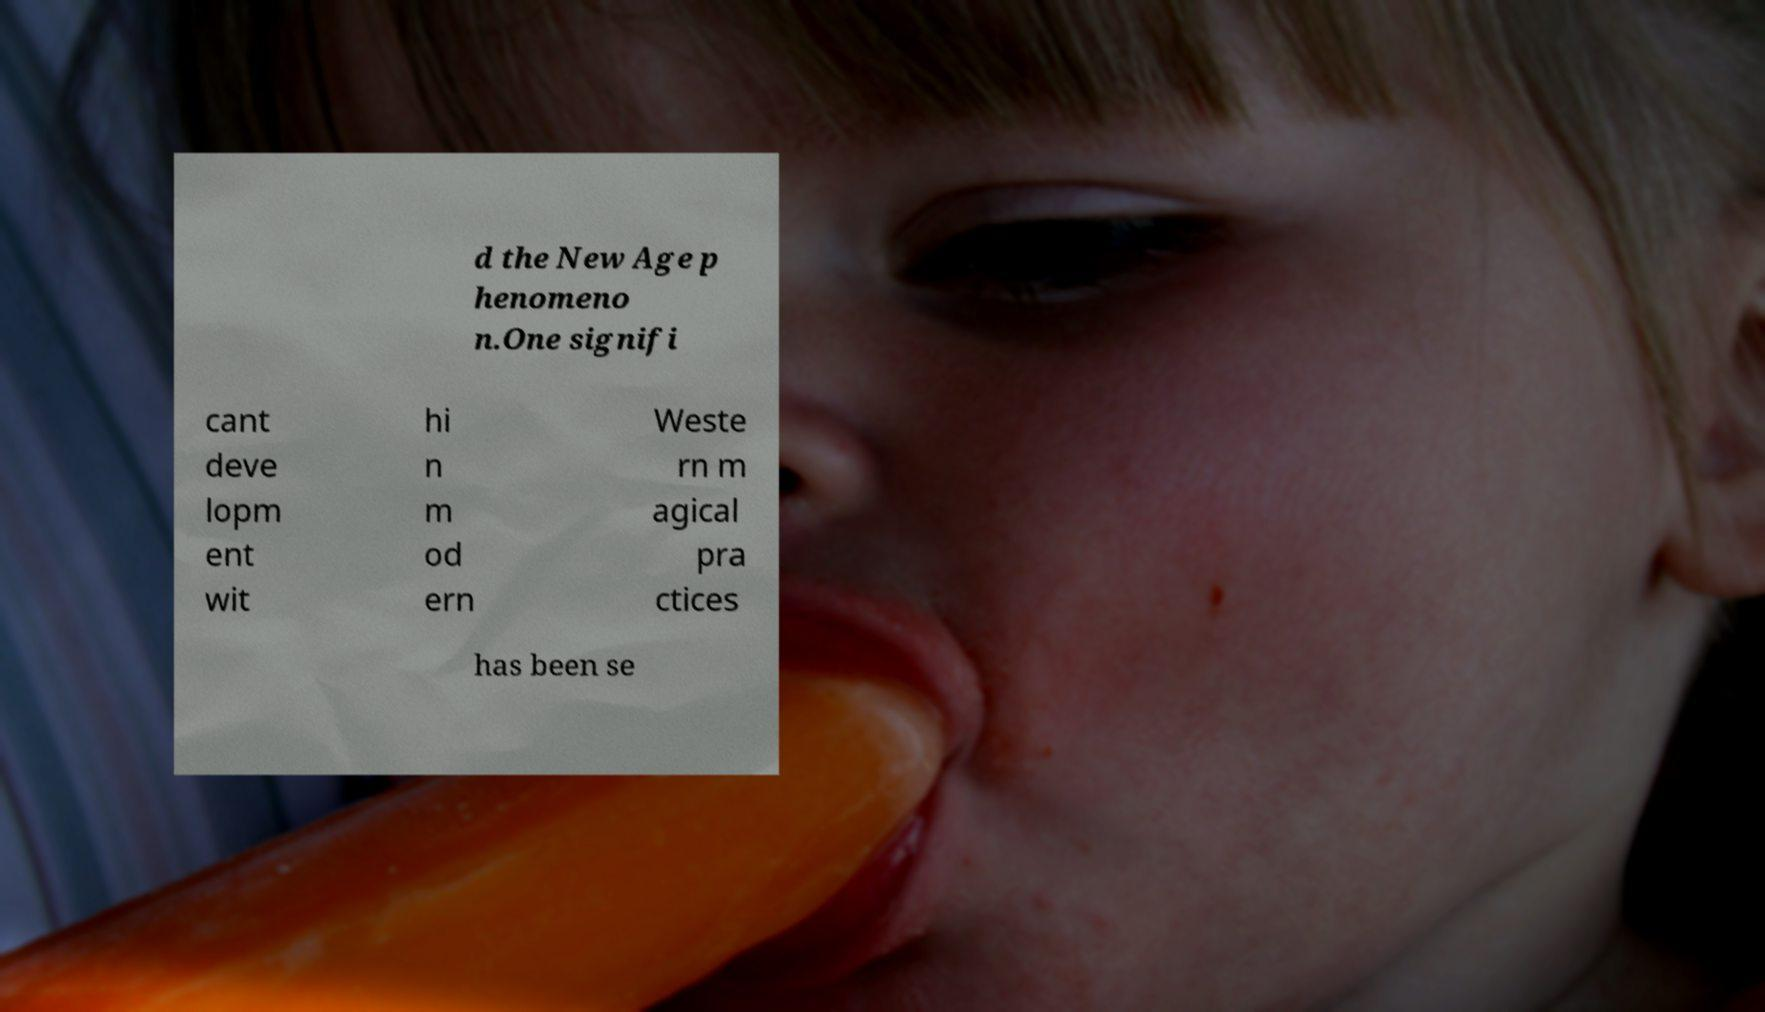For documentation purposes, I need the text within this image transcribed. Could you provide that? d the New Age p henomeno n.One signifi cant deve lopm ent wit hi n m od ern Weste rn m agical pra ctices has been se 